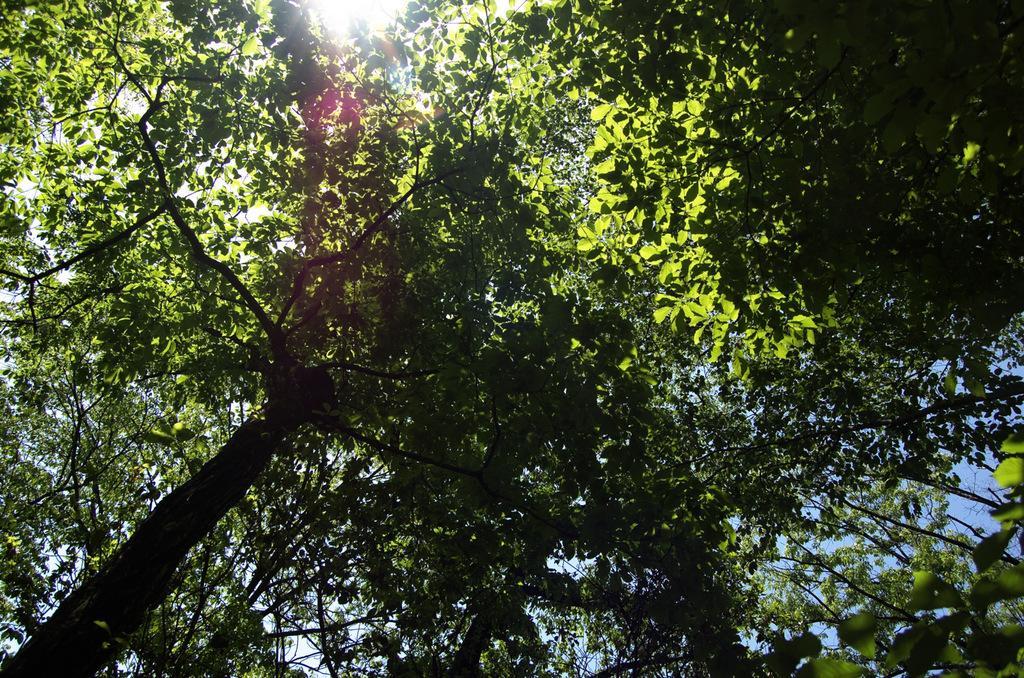Can you describe this image briefly? In the foreground of this image, there are trees. At the top, there is the rays of the sun. 